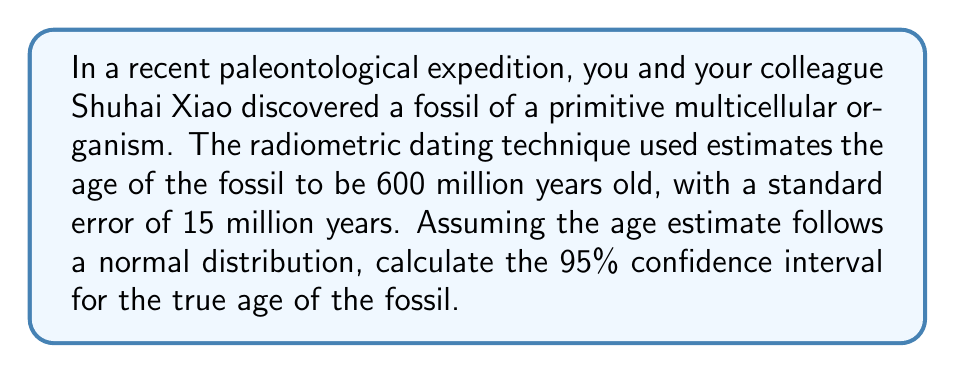Show me your answer to this math problem. To determine the 95% confidence interval, we'll follow these steps:

1) The general formula for a confidence interval is:
   $$ \text{Point Estimate} \pm (\text{Critical Value} \times \text{Standard Error}) $$

2) We know:
   - Point Estimate (mean age) = 600 million years
   - Standard Error = 15 million years
   - Confidence level = 95%

3) For a 95% confidence interval with a normal distribution, the critical value is 1.96 (from the standard normal distribution table).

4) Plugging these values into our formula:
   $$ 600 \pm (1.96 \times 15) $$

5) Simplify:
   $$ 600 \pm 29.4 $$

6) Calculate the lower and upper bounds:
   - Lower bound: $600 - 29.4 = 570.6$ million years
   - Upper bound: $600 + 29.4 = 629.4$ million years

Therefore, we can say with 95% confidence that the true age of the fossil is between 570.6 and 629.4 million years old.
Answer: (570.6, 629.4) million years 